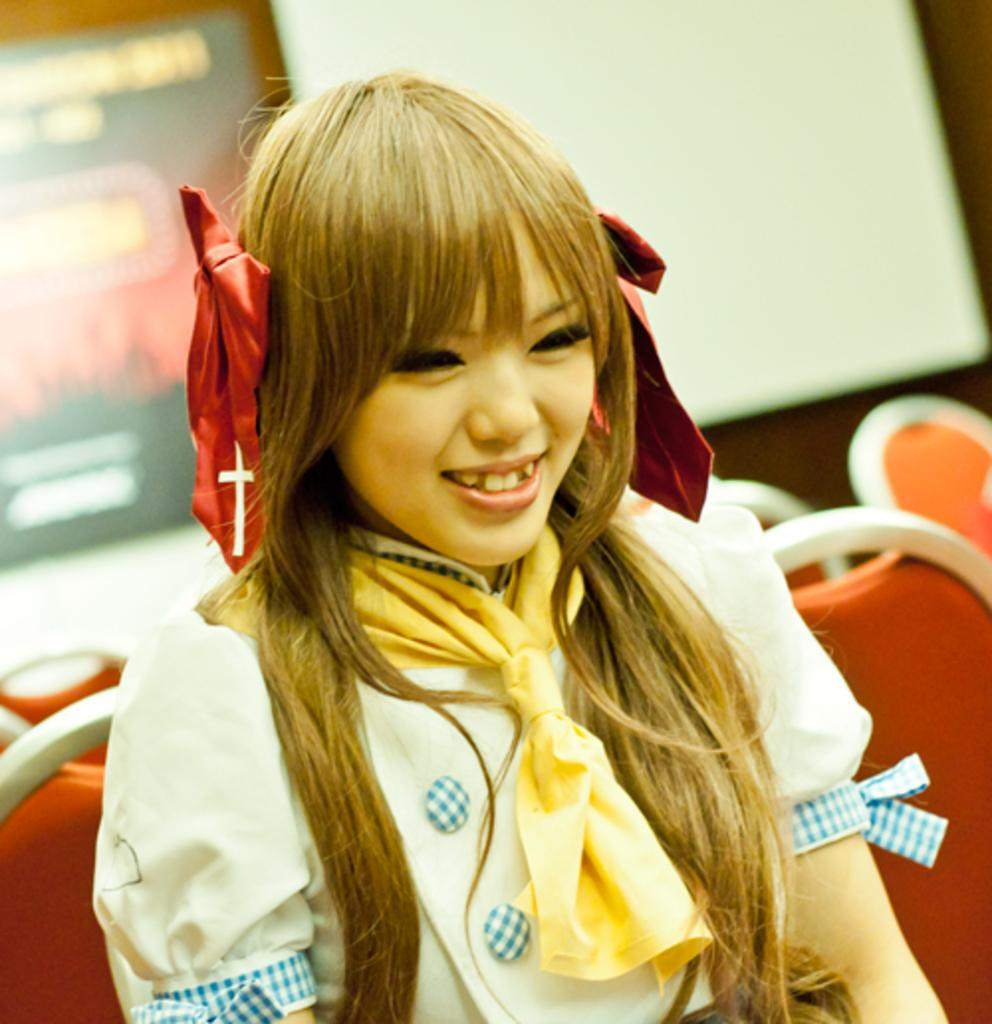Who is present in the image? There is a woman in the image. What expression does the woman have? The woman is smiling. What is the woman doing in the image? The woman is seated on a chair. What type of pancake is the woman holding in the image? There is no pancake present in the image; the woman is seated on a chair and smiling. 